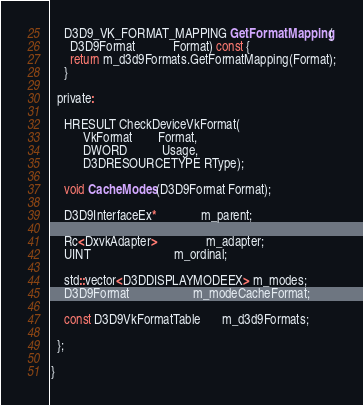Convert code to text. <code><loc_0><loc_0><loc_500><loc_500><_C_>
    D3D9_VK_FORMAT_MAPPING GetFormatMapping(
      D3D9Format            Format) const {
      return m_d3d9Formats.GetFormatMapping(Format);
    }

  private:

    HRESULT CheckDeviceVkFormat(
          VkFormat        Format,
          DWORD           Usage,
          D3DRESOURCETYPE RType);

    void CacheModes(D3D9Format Format);

    D3D9InterfaceEx*              m_parent;

    Rc<DxvkAdapter>               m_adapter;
    UINT                          m_ordinal;

    std::vector<D3DDISPLAYMODEEX> m_modes;
    D3D9Format                    m_modeCacheFormat;

    const D3D9VkFormatTable       m_d3d9Formats;

  };

}</code> 